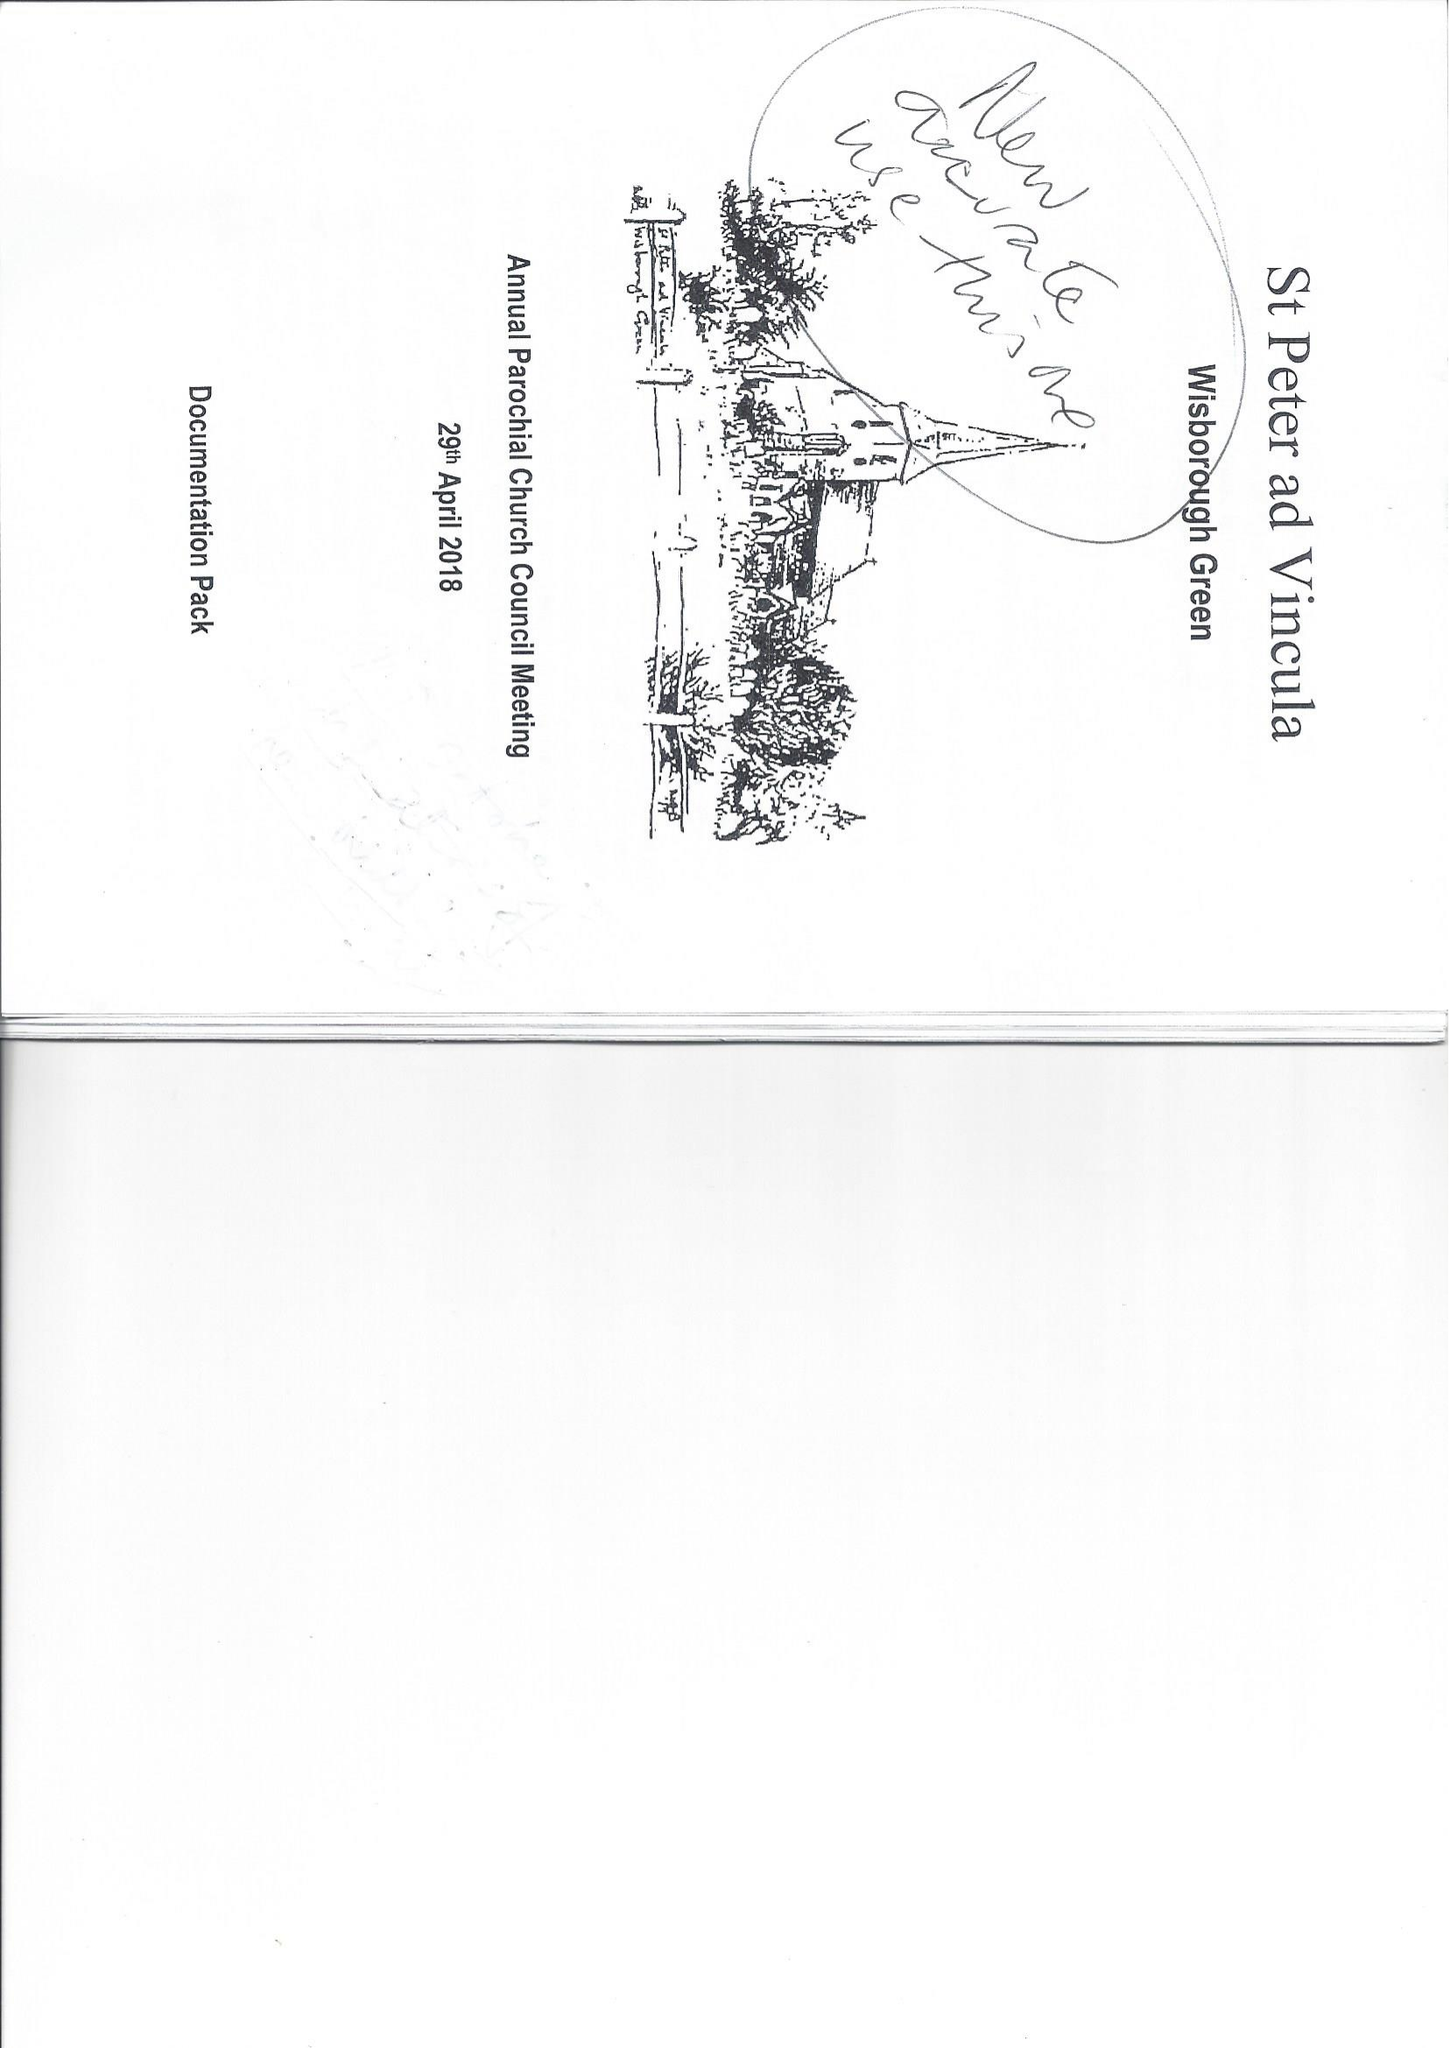What is the value for the report_date?
Answer the question using a single word or phrase. 2017-12-31 